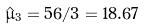<formula> <loc_0><loc_0><loc_500><loc_500>\hat { \mu } _ { 3 } = 5 6 / 3 = 1 8 . 6 7</formula> 